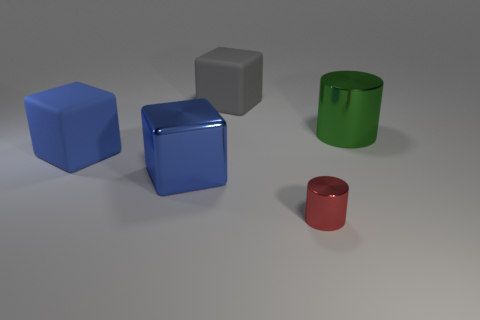Are there any other things that have the same size as the red metal cylinder?
Make the answer very short. No. What shape is the green object that is made of the same material as the small red thing?
Ensure brevity in your answer.  Cylinder. Are there any other things that are the same color as the large metallic cylinder?
Provide a short and direct response. No. There is a large green thing that is the same shape as the small thing; what material is it?
Offer a terse response. Metal. What number of other objects are the same size as the red shiny object?
Offer a very short reply. 0. What is the material of the red thing?
Your answer should be very brief. Metal. Are there more large green shiny things in front of the tiny red thing than large blue balls?
Your answer should be very brief. No. Are there any cyan cylinders?
Ensure brevity in your answer.  No. What number of other things are there of the same shape as the gray matte thing?
Make the answer very short. 2. There is a metal object to the right of the tiny red shiny cylinder; does it have the same color as the cube on the right side of the shiny block?
Give a very brief answer. No. 